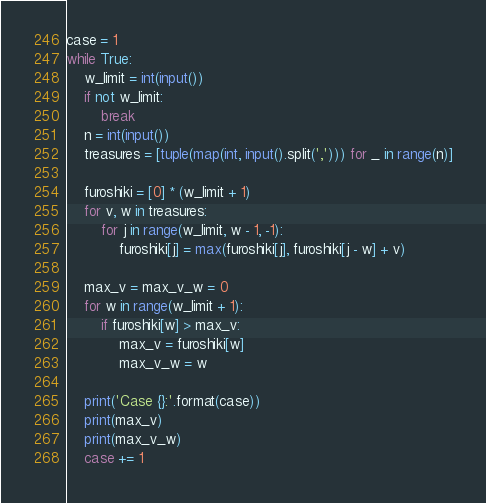<code> <loc_0><loc_0><loc_500><loc_500><_Python_>case = 1
while True:
    w_limit = int(input())
    if not w_limit:
        break
    n = int(input())
    treasures = [tuple(map(int, input().split(','))) for _ in range(n)]

    furoshiki = [0] * (w_limit + 1)
    for v, w in treasures:
        for j in range(w_limit, w - 1, -1):
            furoshiki[j] = max(furoshiki[j], furoshiki[j - w] + v)

    max_v = max_v_w = 0
    for w in range(w_limit + 1):
        if furoshiki[w] > max_v:
            max_v = furoshiki[w]
            max_v_w = w

    print('Case {}:'.format(case))
    print(max_v)
    print(max_v_w)
    case += 1</code> 